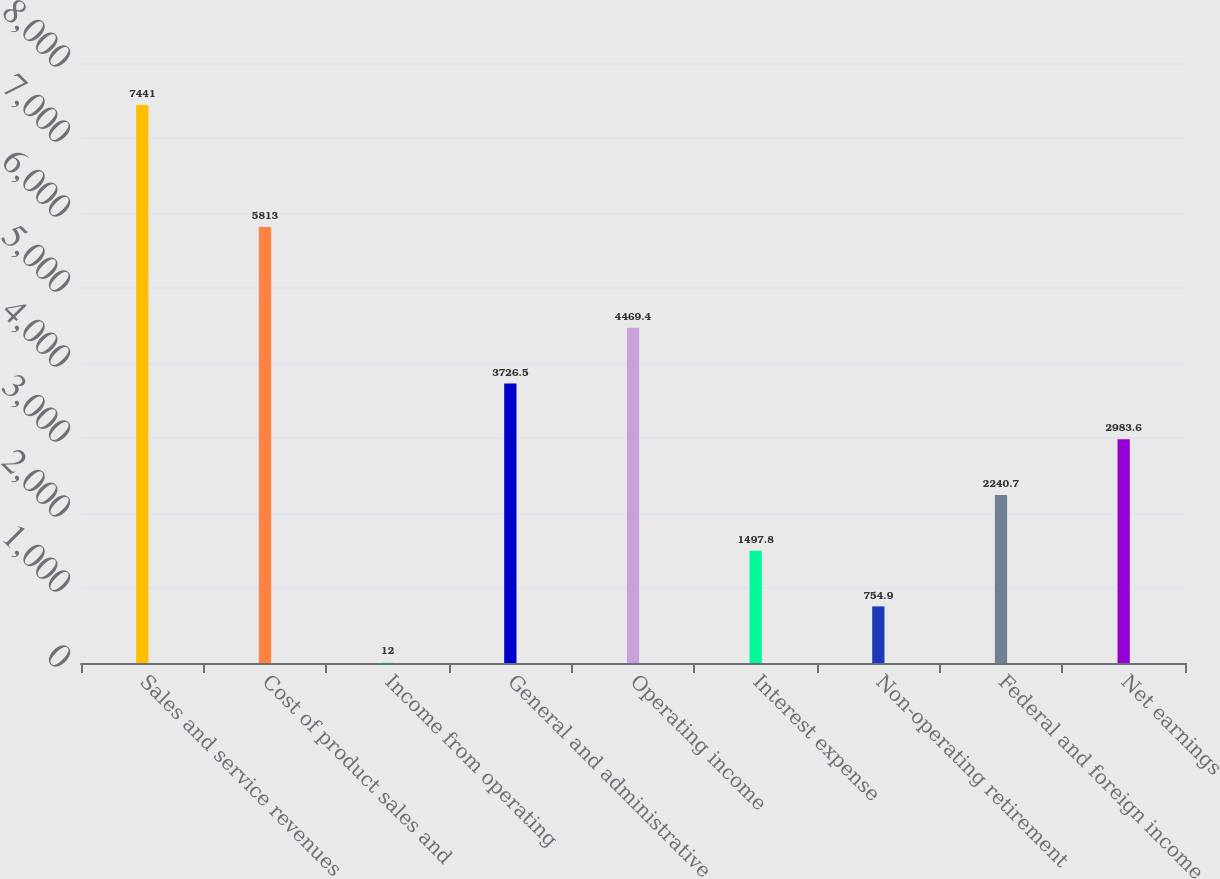Convert chart to OTSL. <chart><loc_0><loc_0><loc_500><loc_500><bar_chart><fcel>Sales and service revenues<fcel>Cost of product sales and<fcel>Income from operating<fcel>General and administrative<fcel>Operating income<fcel>Interest expense<fcel>Non-operating retirement<fcel>Federal and foreign income<fcel>Net earnings<nl><fcel>7441<fcel>5813<fcel>12<fcel>3726.5<fcel>4469.4<fcel>1497.8<fcel>754.9<fcel>2240.7<fcel>2983.6<nl></chart> 